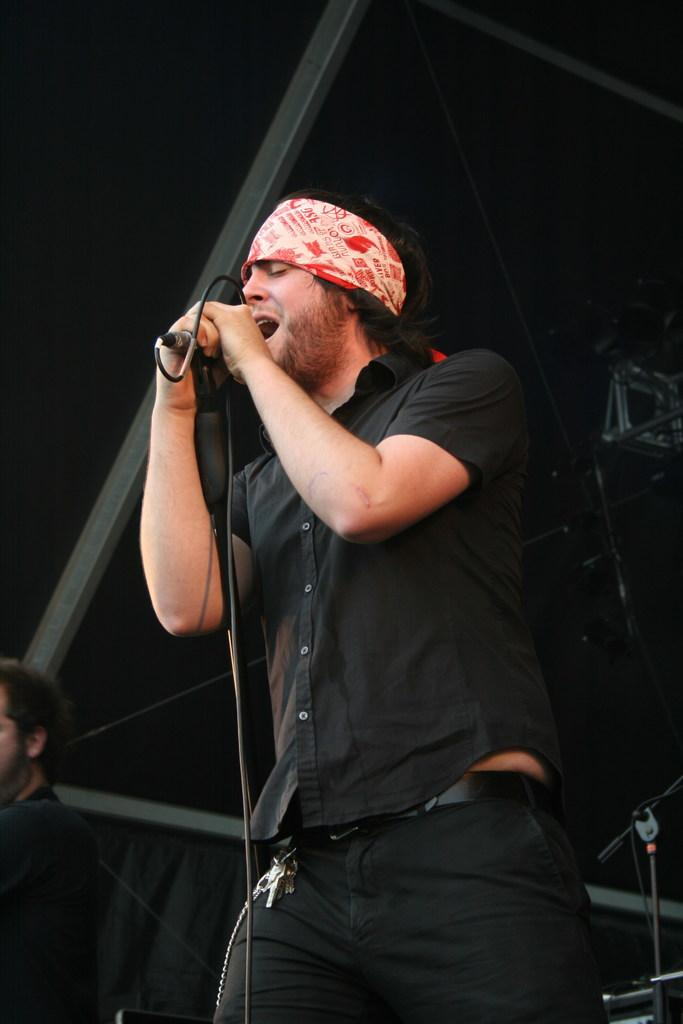What is the main activity of the person in the image? The person is singing on a microphone. Is there anyone else present in the image? Yes, there is another person beside the person singing. What might the second person be doing in the image? The second person might be accompanying the singer, providing musical support, or simply observing the performance. What type of house is visible in the background of the image? There is no house visible in the background of the image; it is focused on the person singing and the second person. 